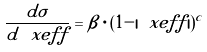<formula> <loc_0><loc_0><loc_500><loc_500>\frac { d \sigma } { d \ x e f f } = \beta \cdot ( 1 - | \ x e f f | ) ^ { c }</formula> 